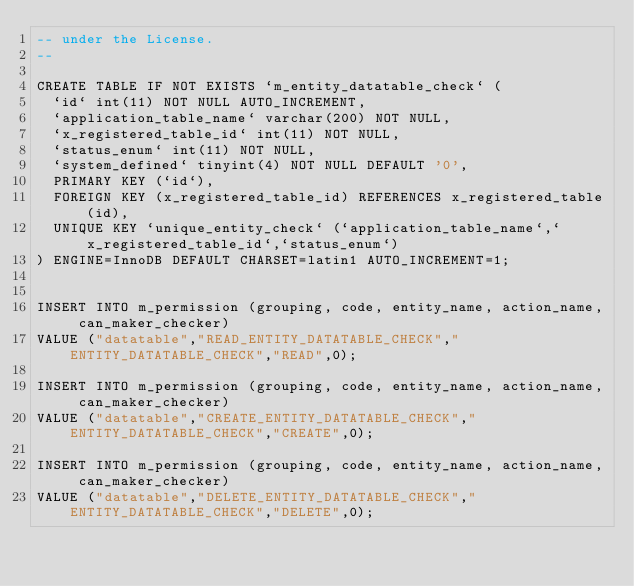Convert code to text. <code><loc_0><loc_0><loc_500><loc_500><_SQL_>-- under the License.
--

CREATE TABLE IF NOT EXISTS `m_entity_datatable_check` (
  `id` int(11) NOT NULL AUTO_INCREMENT,
  `application_table_name` varchar(200) NOT NULL,
  `x_registered_table_id` int(11) NOT NULL,
  `status_enum` int(11) NOT NULL,
  `system_defined` tinyint(4) NOT NULL DEFAULT '0',
  PRIMARY KEY (`id`),
  FOREIGN KEY (x_registered_table_id) REFERENCES x_registered_table(id),
  UNIQUE KEY `unique_entity_check` (`application_table_name`,`x_registered_table_id`,`status_enum`)
) ENGINE=InnoDB DEFAULT CHARSET=latin1 AUTO_INCREMENT=1;


INSERT INTO m_permission (grouping, code, entity_name, action_name, can_maker_checker)
VALUE ("datatable","READ_ENTITY_DATATABLE_CHECK","ENTITY_DATATABLE_CHECK","READ",0);

INSERT INTO m_permission (grouping, code, entity_name, action_name, can_maker_checker)
VALUE ("datatable","CREATE_ENTITY_DATATABLE_CHECK","ENTITY_DATATABLE_CHECK","CREATE",0);

INSERT INTO m_permission (grouping, code, entity_name, action_name, can_maker_checker)
VALUE ("datatable","DELETE_ENTITY_DATATABLE_CHECK","ENTITY_DATATABLE_CHECK","DELETE",0);


</code> 